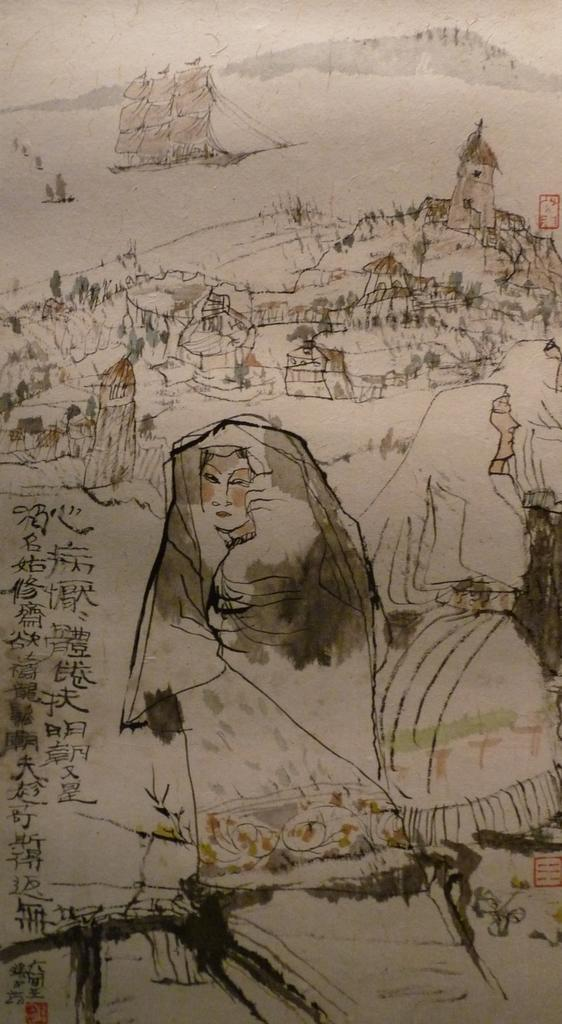What is depicted in the drawing in the image? There is a drawing of pyramids in the image. What else can be found in the image besides the drawing? There is text in the image. What type of knife is being used to play with the toys in the image? There is no knife or toys present in the image; it only contains a drawing of pyramids and text. 